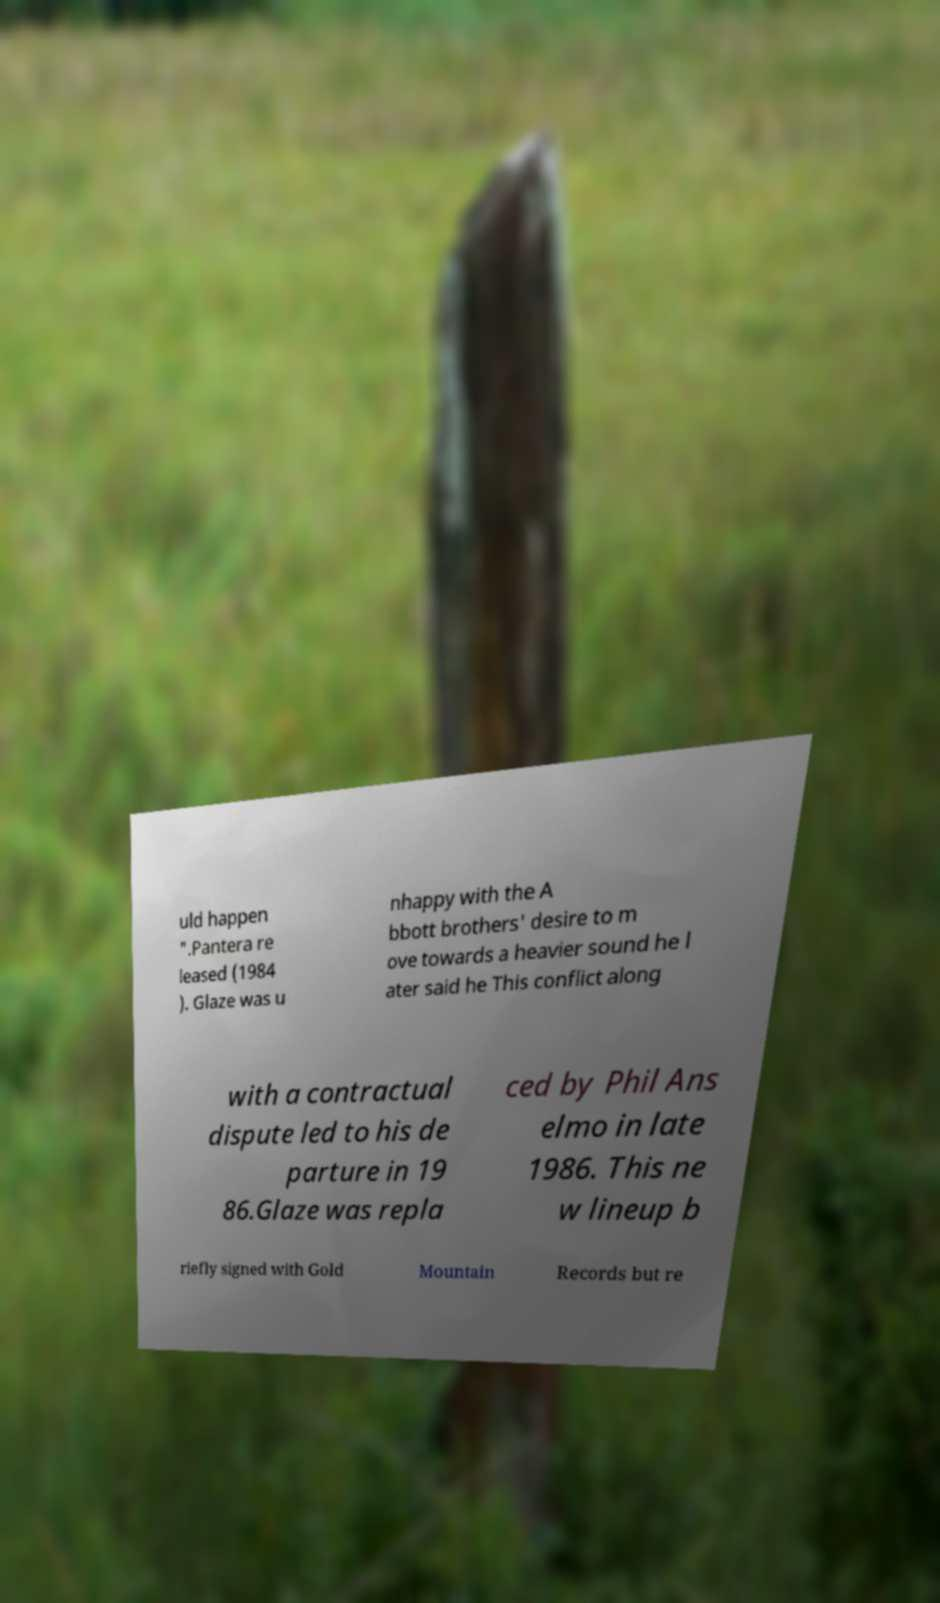Could you assist in decoding the text presented in this image and type it out clearly? uld happen ".Pantera re leased (1984 ). Glaze was u nhappy with the A bbott brothers' desire to m ove towards a heavier sound he l ater said he This conflict along with a contractual dispute led to his de parture in 19 86.Glaze was repla ced by Phil Ans elmo in late 1986. This ne w lineup b riefly signed with Gold Mountain Records but re 